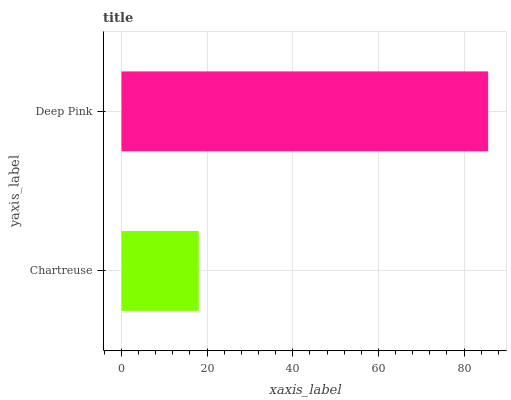Is Chartreuse the minimum?
Answer yes or no. Yes. Is Deep Pink the maximum?
Answer yes or no. Yes. Is Deep Pink the minimum?
Answer yes or no. No. Is Deep Pink greater than Chartreuse?
Answer yes or no. Yes. Is Chartreuse less than Deep Pink?
Answer yes or no. Yes. Is Chartreuse greater than Deep Pink?
Answer yes or no. No. Is Deep Pink less than Chartreuse?
Answer yes or no. No. Is Deep Pink the high median?
Answer yes or no. Yes. Is Chartreuse the low median?
Answer yes or no. Yes. Is Chartreuse the high median?
Answer yes or no. No. Is Deep Pink the low median?
Answer yes or no. No. 